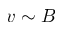<formula> <loc_0><loc_0><loc_500><loc_500>v \sim B</formula> 